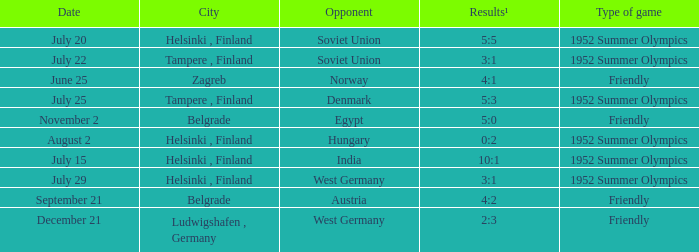What is the name of the metropolis with december 21 as a date? Ludwigshafen , Germany. 